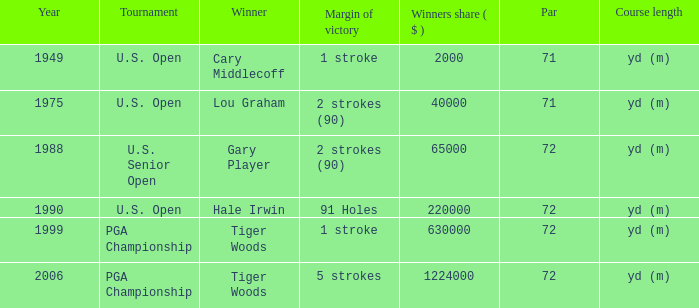When hale irwin prevails, what is the margin of triumph? 91 Holes. 